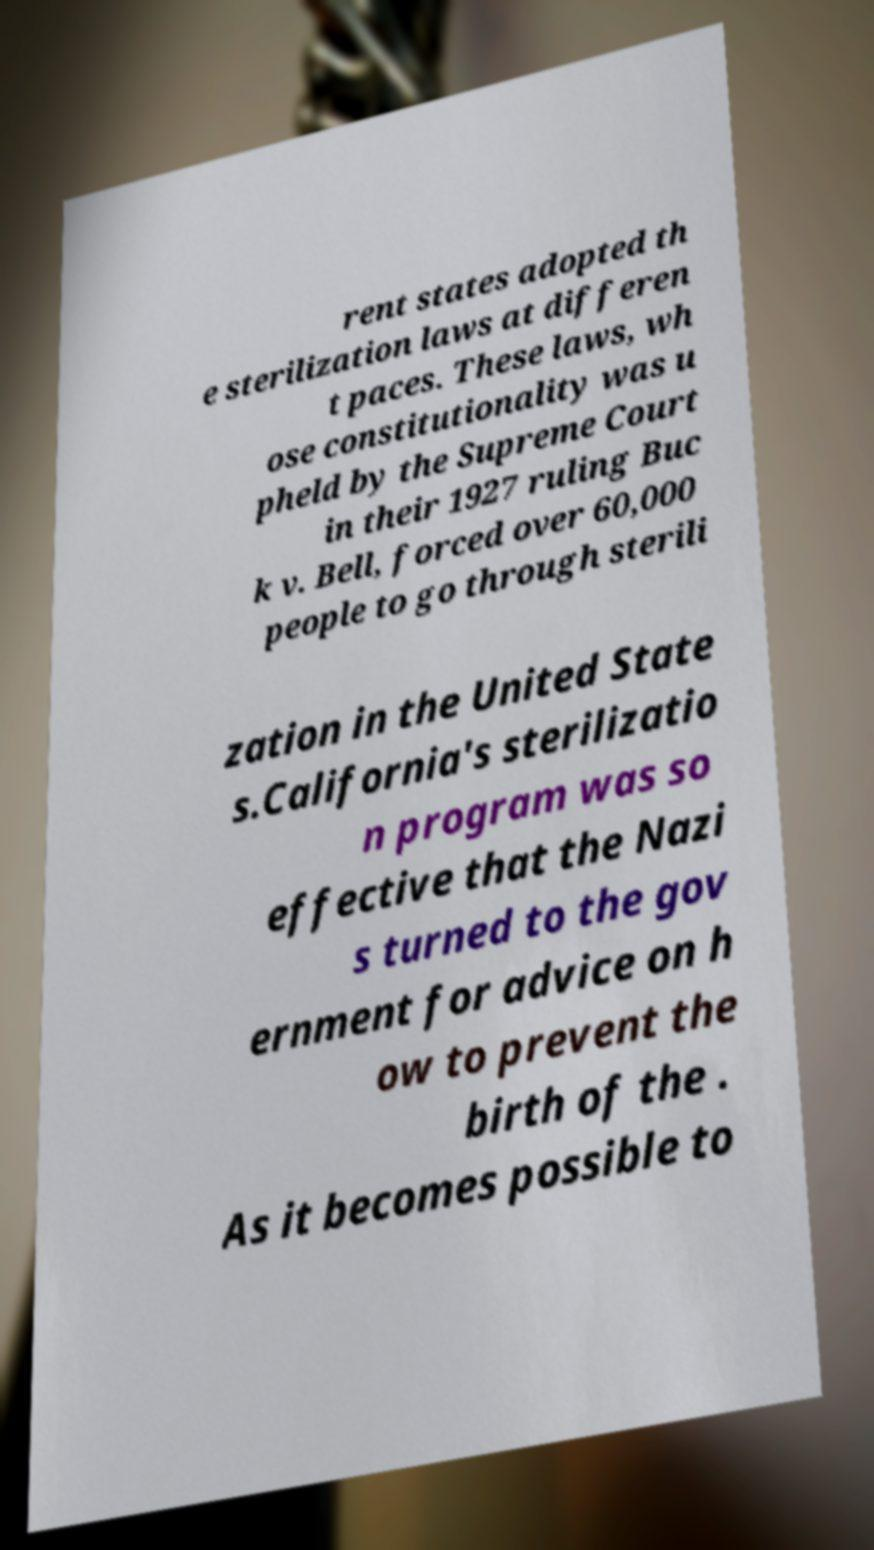Can you accurately transcribe the text from the provided image for me? rent states adopted th e sterilization laws at differen t paces. These laws, wh ose constitutionality was u pheld by the Supreme Court in their 1927 ruling Buc k v. Bell, forced over 60,000 people to go through sterili zation in the United State s.California's sterilizatio n program was so effective that the Nazi s turned to the gov ernment for advice on h ow to prevent the birth of the . As it becomes possible to 